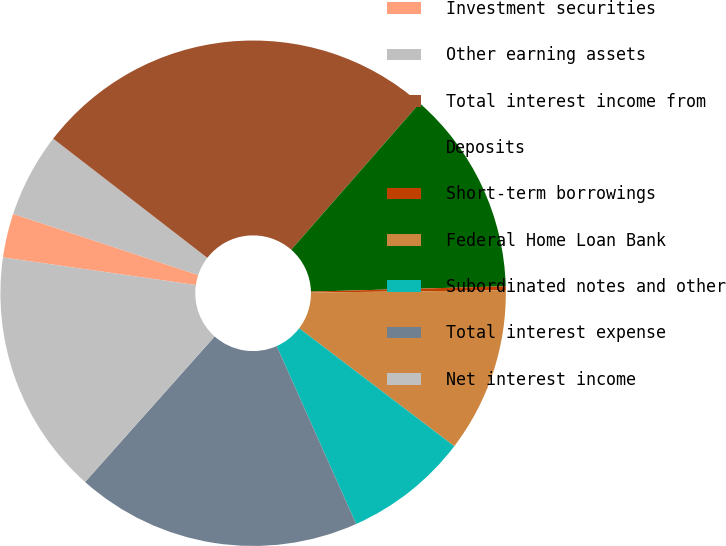Convert chart to OTSL. <chart><loc_0><loc_0><loc_500><loc_500><pie_chart><fcel>Investment securities<fcel>Other earning assets<fcel>Total interest income from<fcel>Deposits<fcel>Short-term borrowings<fcel>Federal Home Loan Bank<fcel>Subordinated notes and other<fcel>Total interest expense<fcel>Net interest income<nl><fcel>2.82%<fcel>5.39%<fcel>25.98%<fcel>13.11%<fcel>0.25%<fcel>10.54%<fcel>7.97%<fcel>18.26%<fcel>15.69%<nl></chart> 